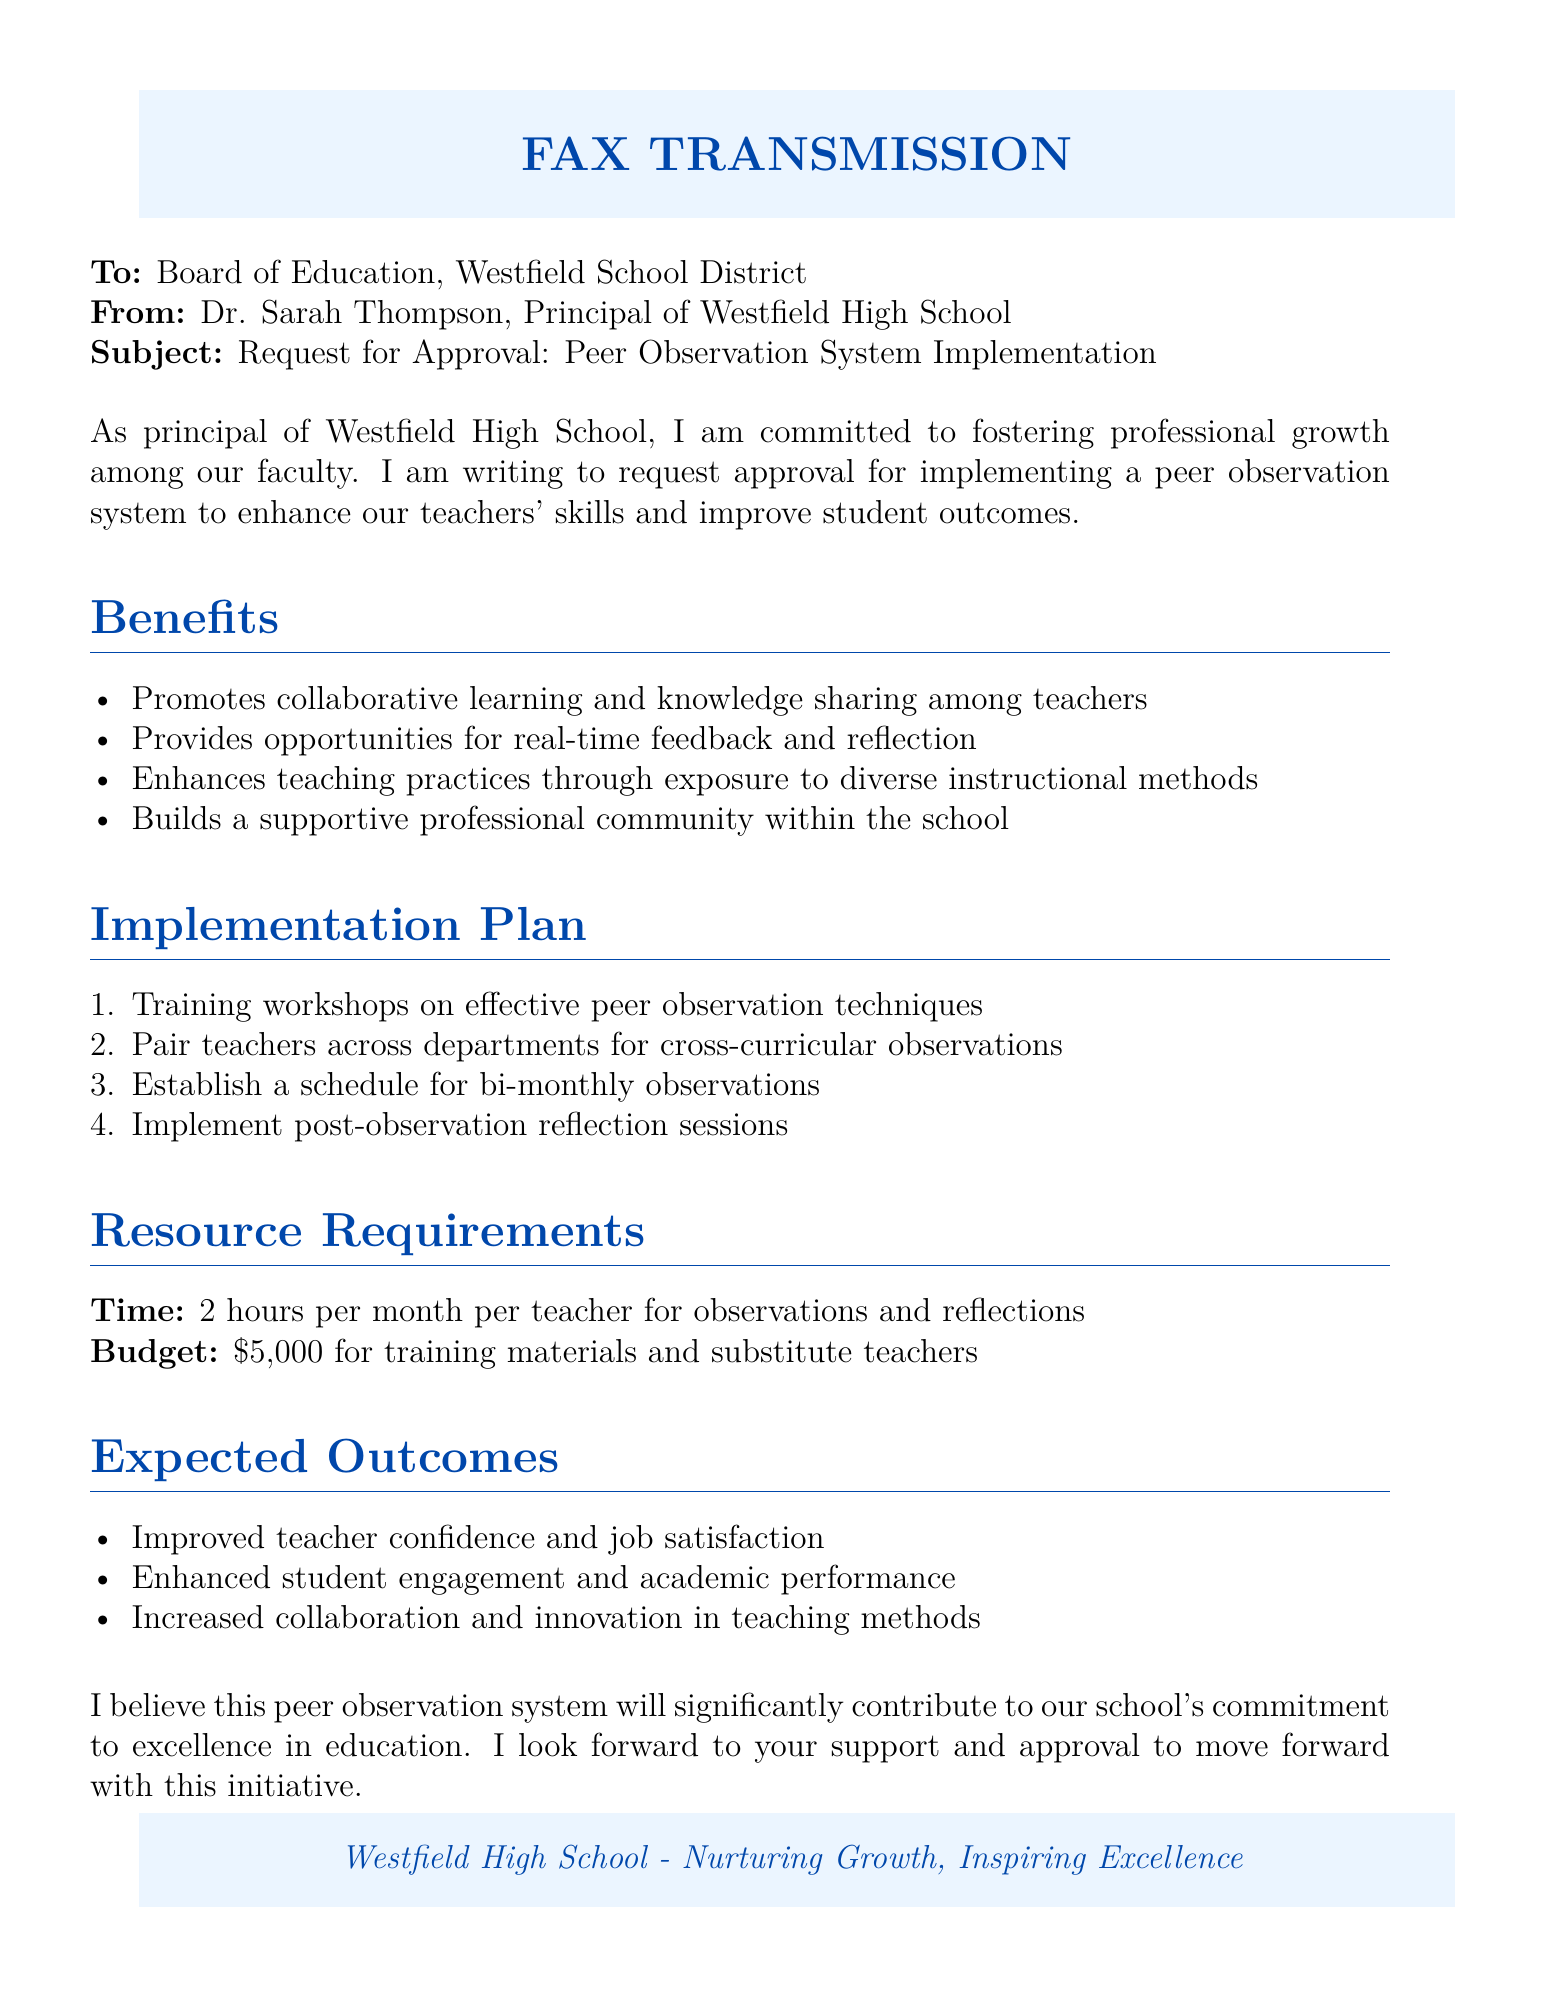What is the subject of the fax? The subject line specifies the topic of the fax, which is the request for approval for a new initiative.
Answer: Request for Approval: Peer Observation System Implementation Who is the sender of the fax? The sender is identified in the document by the name and title at the beginning.
Answer: Dr. Sarah Thompson, Principal of Westfield High School What is the budget required for implementing the peer observation system? The budget section outlines the financial requirement for the initiative.
Answer: $5,000 What is the expected time commitment per teacher per month for the program? The resource requirements section mentions the time expected from each teacher.
Answer: 2 hours What is one major benefit of the peer observation system mentioned in the fax? The benefits section lists several advantages, indicative of the program's purpose.
Answer: Promotes collaborative learning How many training workshops are planned for the peer observation system? The implementation plan outlines the training steps, where each step can indicate a different aspect of the rollout.
Answer: One (training workshops) What is the frequency of observations scheduled as per the implementation plan? The implementation plan specifies how often the observations will occur.
Answer: Bi-monthly What type of community does the peer observation system aim to build? The benefits section suggests the type of environment the initiative is trying to foster among faculty.
Answer: Supportive professional community What is the main purpose of the peer observation system according to the fax? The opening statements clarify the overall goal of the initiative being proposed.
Answer: Enhance our teachers' skills and improve student outcomes 